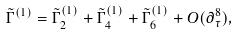Convert formula to latex. <formula><loc_0><loc_0><loc_500><loc_500>\tilde { \Gamma } ^ { ( 1 ) } = \tilde { \Gamma } ^ { ( 1 ) } _ { 2 } + \tilde { \Gamma } ^ { ( 1 ) } _ { 4 } + \tilde { \Gamma } ^ { ( 1 ) } _ { 6 } + O ( \partial _ { \tau } ^ { 8 } ) ,</formula> 